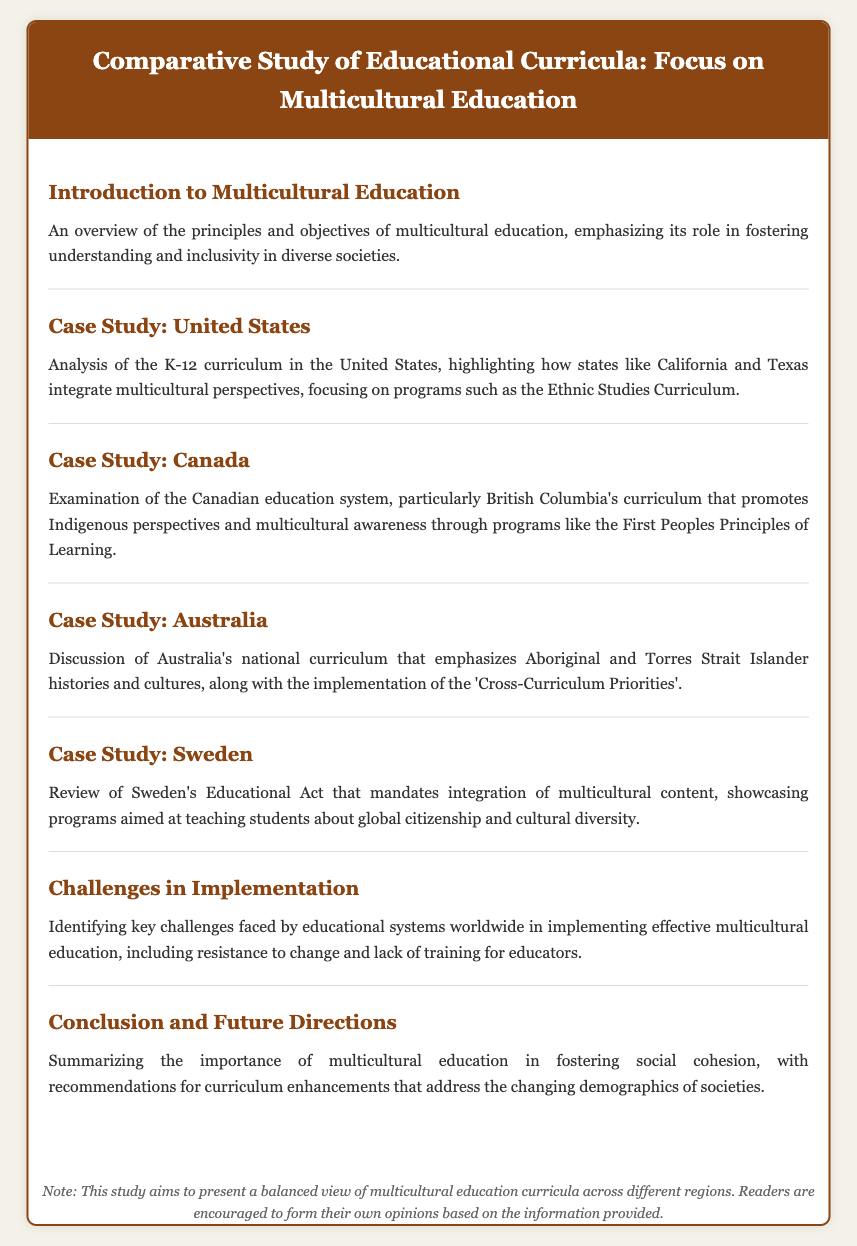What is the focus of the study? The study focuses on the educational curricula across different regions with an emphasis on multicultural education.
Answer: Multicultural education Which case study examines the Canadian education system? The case study specifically analyzing the Canadian education system is titled "Case Study: Canada".
Answer: Case Study: Canada What program is highlighted in the United States case study? The program that is highlighted in the U.S. case study is the Ethnic Studies Curriculum.
Answer: Ethnic Studies Curriculum What is mandated by Sweden's Educational Act? Sweden's Educational Act mandates the integration of multicultural content in education.
Answer: Integration of multicultural content What is one challenge in implementing multicultural education? A key challenge faced globally in implementing multicultural education is the resistance to change.
Answer: Resistance to change 